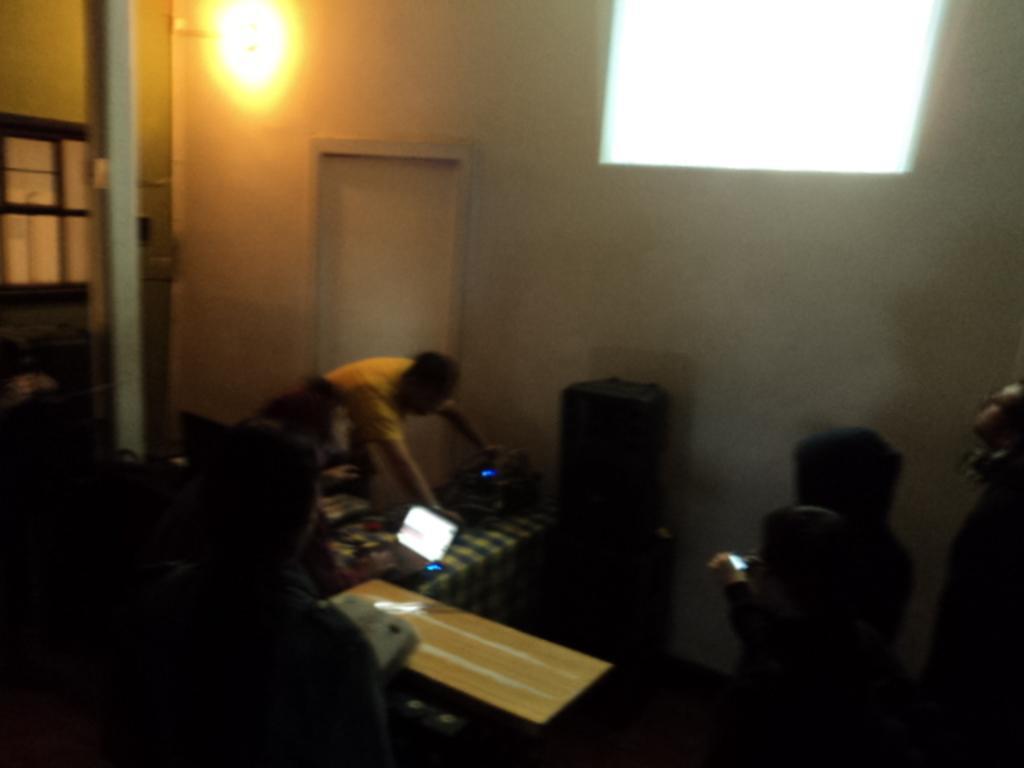How would you summarize this image in a sentence or two? In this image I see few people and there is a laptop over here. In the background I see the wall, door and the light. 